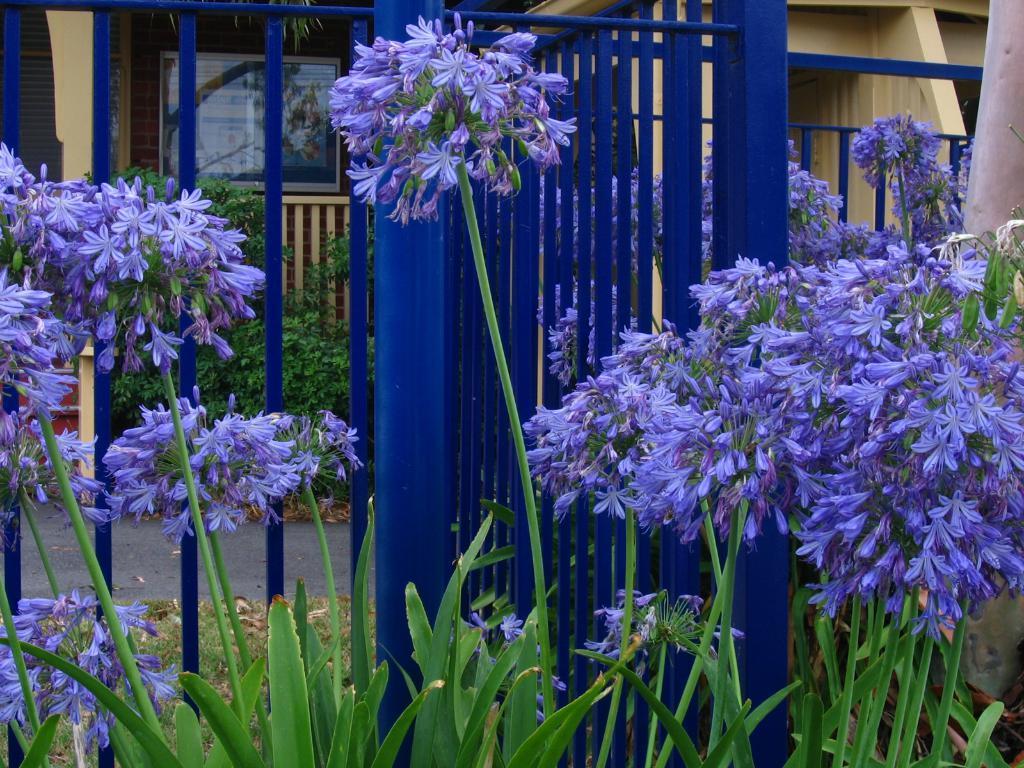How would you summarize this image in a sentence or two? In this image in the foreground there are some plants and flowers, and in the background there are grills and house and some boards and there is a walkway in the center and also there is some grass. 